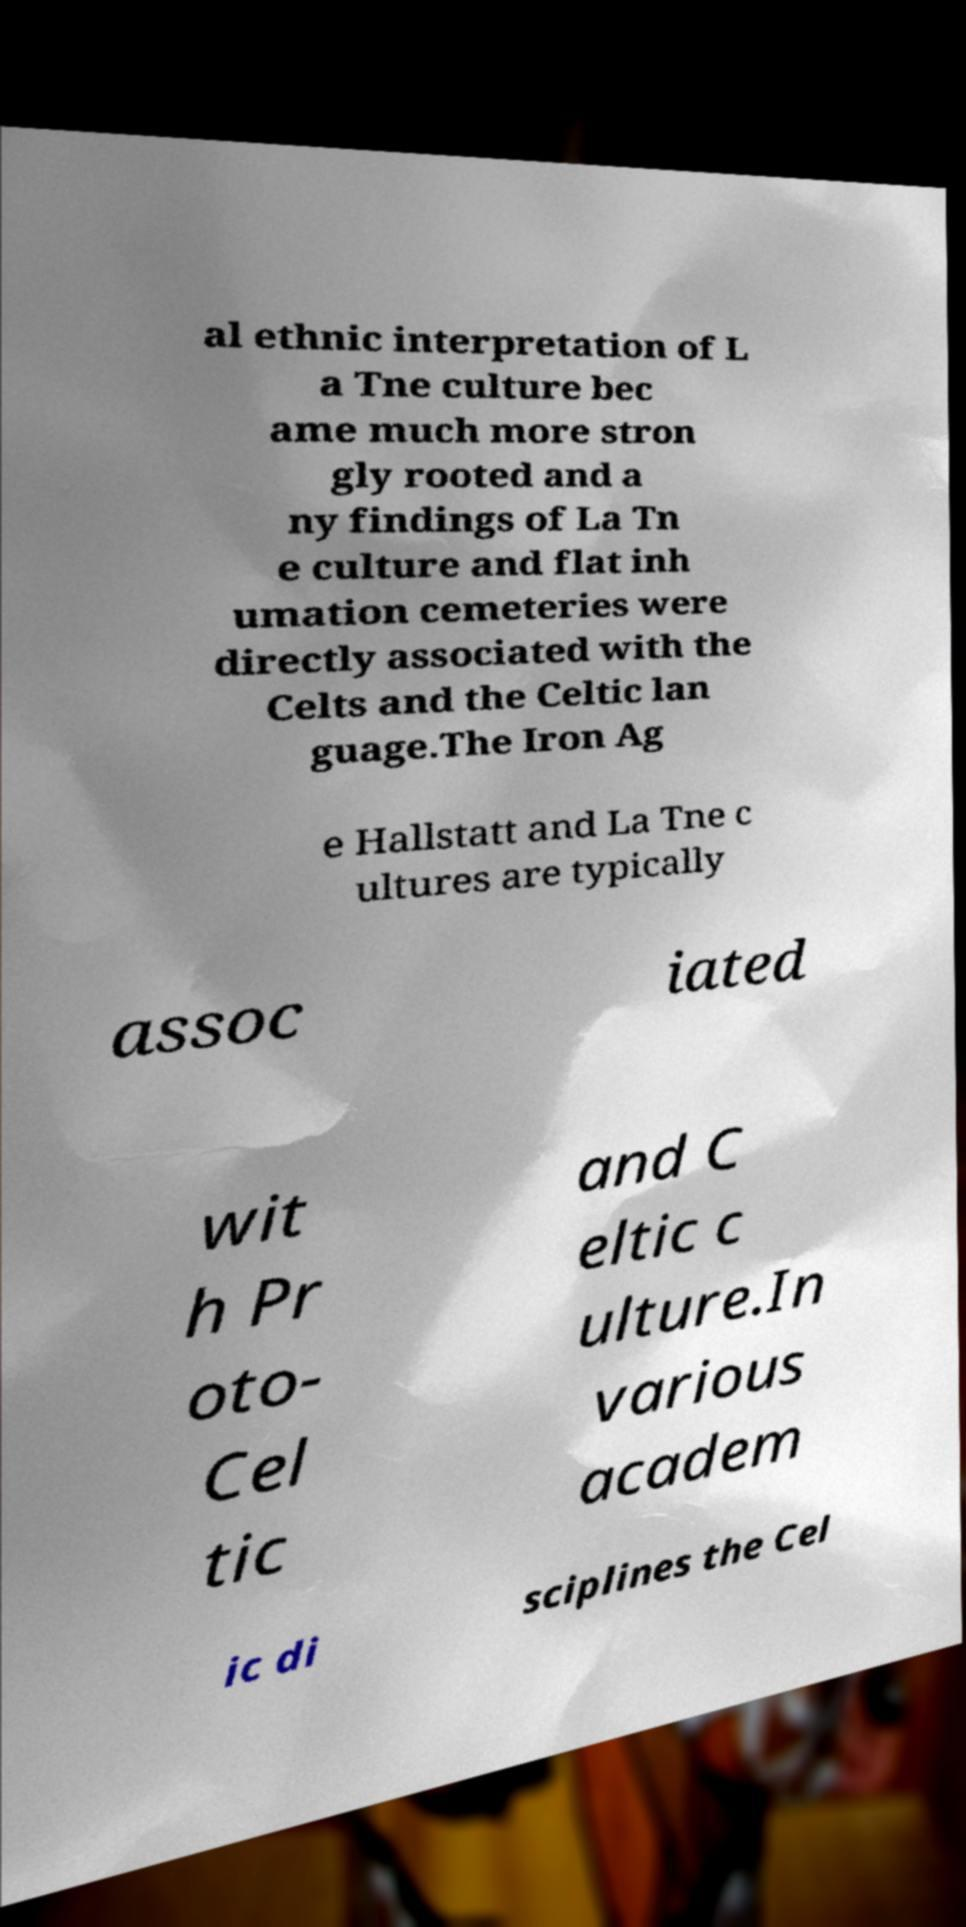For documentation purposes, I need the text within this image transcribed. Could you provide that? al ethnic interpretation of L a Tne culture bec ame much more stron gly rooted and a ny findings of La Tn e culture and flat inh umation cemeteries were directly associated with the Celts and the Celtic lan guage.The Iron Ag e Hallstatt and La Tne c ultures are typically assoc iated wit h Pr oto- Cel tic and C eltic c ulture.In various academ ic di sciplines the Cel 